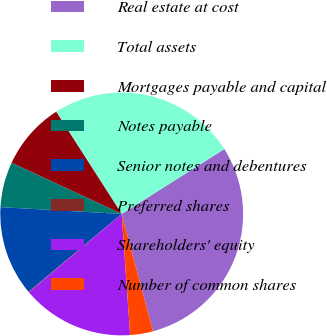<chart> <loc_0><loc_0><loc_500><loc_500><pie_chart><fcel>Real estate at cost<fcel>Total assets<fcel>Mortgages payable and capital<fcel>Notes payable<fcel>Senior notes and debentures<fcel>Preferred shares<fcel>Shareholders' equity<fcel>Number of common shares<nl><fcel>29.81%<fcel>25.1%<fcel>9.0%<fcel>6.03%<fcel>11.97%<fcel>0.08%<fcel>14.95%<fcel>3.05%<nl></chart> 